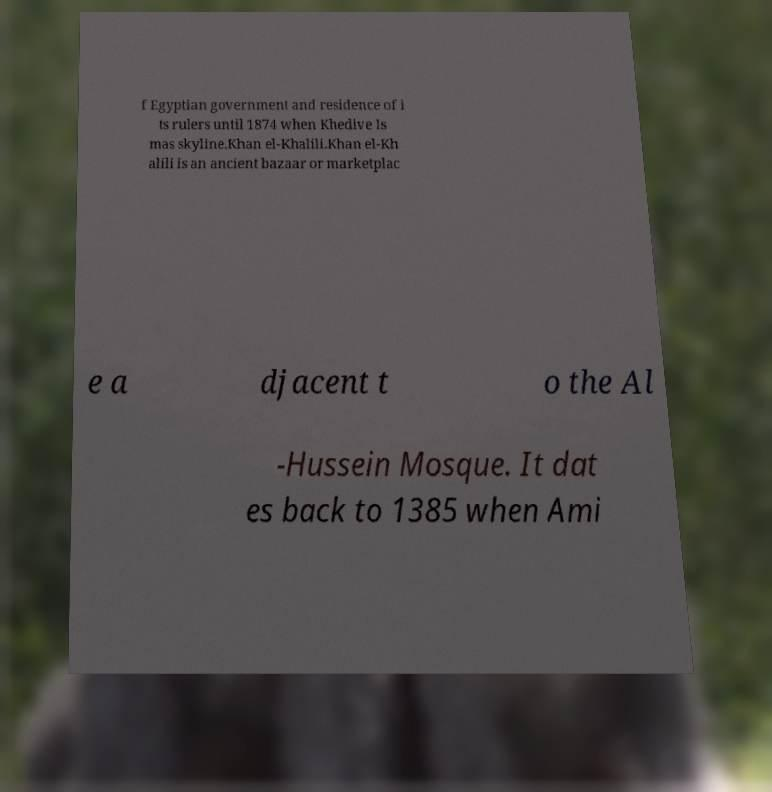There's text embedded in this image that I need extracted. Can you transcribe it verbatim? f Egyptian government and residence of i ts rulers until 1874 when Khedive Is mas skyline.Khan el-Khalili.Khan el-Kh alili is an ancient bazaar or marketplac e a djacent t o the Al -Hussein Mosque. It dat es back to 1385 when Ami 